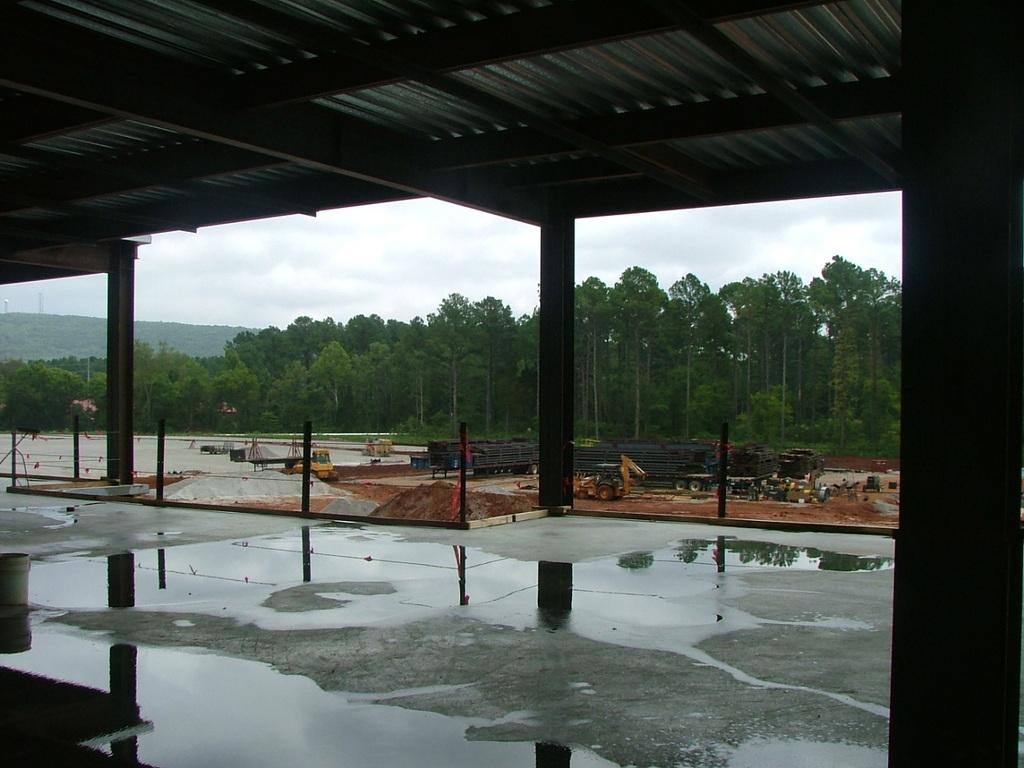What type of structure can be seen in the image? There is a shed in the image. What else is present in the image besides the shed? There are poles, vehicles, and objects on the ground visible in the image. What can be seen in the background of the image? There are trees, mountains, and the sky visible in the background of the image. What is the condition of the sky in the image? Clouds are present in the sky. What type of creature can be seen playing in the sand in the image? There is no creature or sand present in the image. What is the current flowing through the poles in the image? There is no mention of a current or electrical poles in the image; the poles are not specified as electrical. 